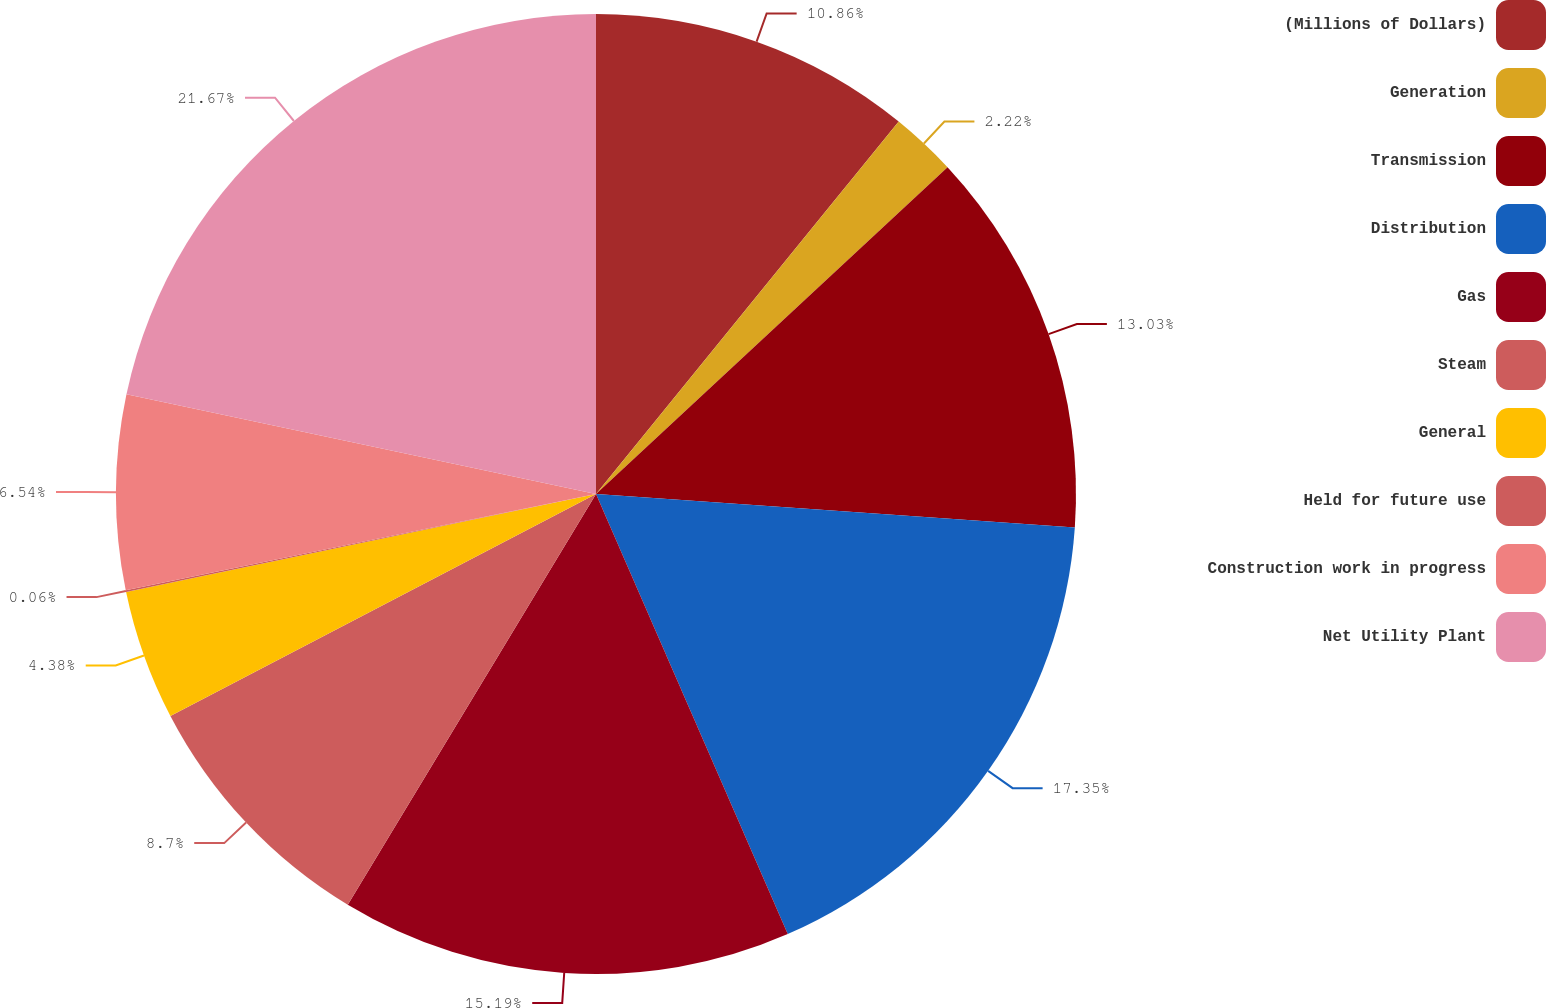<chart> <loc_0><loc_0><loc_500><loc_500><pie_chart><fcel>(Millions of Dollars)<fcel>Generation<fcel>Transmission<fcel>Distribution<fcel>Gas<fcel>Steam<fcel>General<fcel>Held for future use<fcel>Construction work in progress<fcel>Net Utility Plant<nl><fcel>10.86%<fcel>2.22%<fcel>13.03%<fcel>17.35%<fcel>15.19%<fcel>8.7%<fcel>4.38%<fcel>0.06%<fcel>6.54%<fcel>21.67%<nl></chart> 